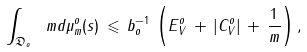<formula> <loc_0><loc_0><loc_500><loc_500>\int _ { \mathfrak { D } _ { o } } \ m d \mu _ { m } ^ { o } ( s ) \, \leqslant \, b _ { o } ^ { - 1 } \, \left ( E _ { V } ^ { o } \, + \, | C _ { V } ^ { o } | \, + \, \frac { 1 } { m } \right ) ,</formula> 